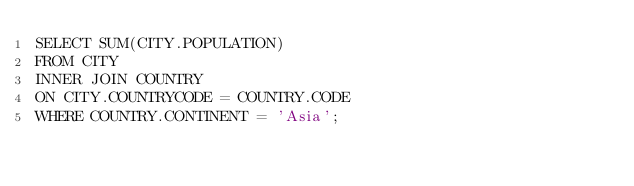<code> <loc_0><loc_0><loc_500><loc_500><_SQL_>SELECT SUM(CITY.POPULATION)
FROM CITY 
INNER JOIN COUNTRY 
ON CITY.COUNTRYCODE = COUNTRY.CODE 
WHERE COUNTRY.CONTINENT = 'Asia';
</code> 